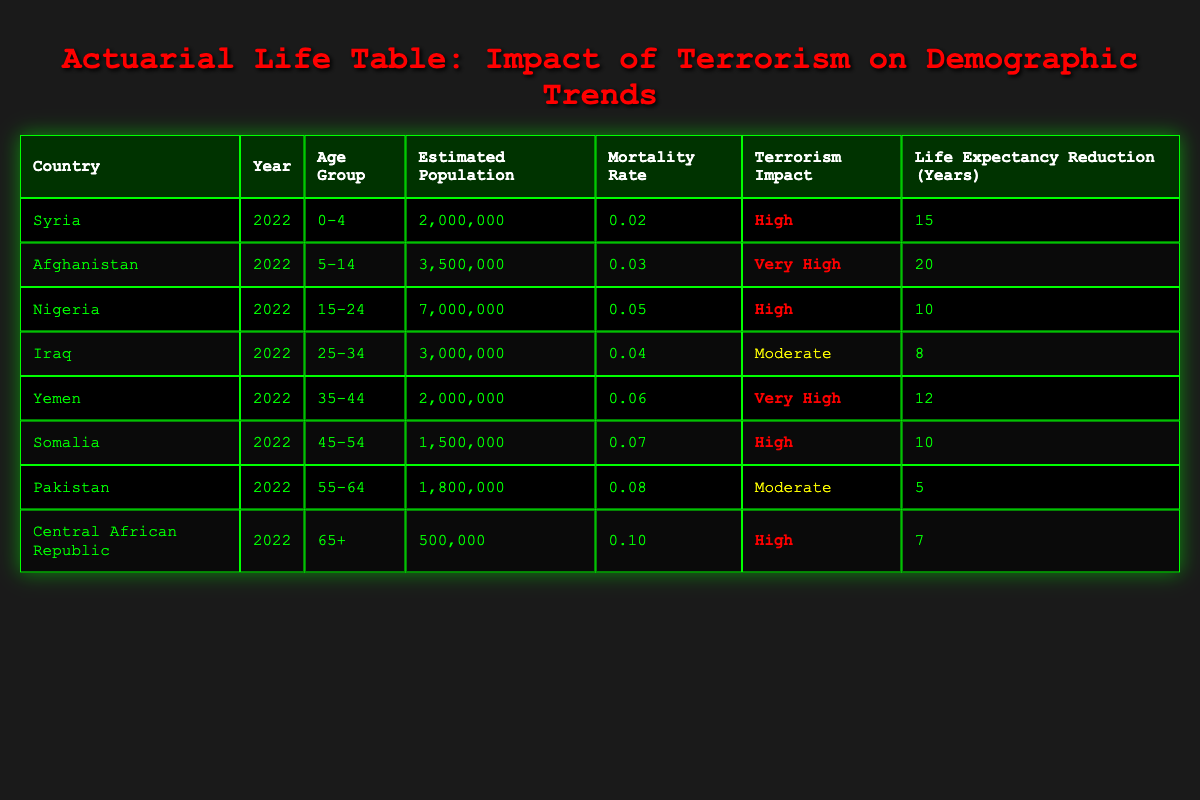What is the terrorism impact in Afghanistan for the age group 5-14? According to the table, Afghanistan has a terrorism impact categorized as "Very High" for the age group 5-14. This information is listed under the respective row for Afghanistan.
Answer: Very High Which country has the highest mortality rate and what is that rate? The table shows that the Central African Republic has the highest mortality rate of 0.10. This is found in the row corresponding to the Central African Republic, specifically for the age group 65+.
Answer: 0.10 What is the total estimated population across all age groups for Nigeria? The table lists Nigeria with an estimated population of 7,000,000 for the age group 15-24. Since it only provides data for this group, this is the total for Nigeria as displayed.
Answer: 7,000,000 What is the average life expectancy reduction for countries with a high terrorism impact? The countries with a high terrorism impact are Syria, Nigeria, Somalia, and Central African Republic. The life expectancy reductions for these countries are 15, 10, 10, and 7 years respectively. The average is calculated as (15 + 10 + 10 + 7) / 4 = 10.5.
Answer: 10.5 Is the life expectancy reduction higher in Yemen than in Iraq? The life expectancy reduction for Yemen is 12 years while for Iraq it is 8 years. Since 12 is greater than 8, the statement is true.
Answer: Yes What is the total estimate of populations for age groups where the terrorism impact is classified as "Very High"? The countries classified with "Very High" terrorism impact are Afghanistan and Yemen. The estimated populations are 3,500,000 (Afghanistan) and 2,000,000 (Yemen). The total is calculated as 3,500,000 + 2,000,000 = 5,500,000.
Answer: 5,500,000 For which age group is the lowest life expectancy reduction observed and what is its value? The lowest life expectancy reduction is seen in Pakistan for the age group 55-64, where it is 5 years. This can be identified by reviewing the life expectancy reduction data in the table.
Answer: 5 Are there more people estimated in the 35-44 age group in Yemen than in the 25-34 age group in Iraq? According to the data, Yemen has an estimated population of 2,000,000 in the 35-44 age group, while Iraq has 3,000,000 in the 25-34 age group. Since 2,000,000 is less than 3,000,000, the statement is false.
Answer: No 